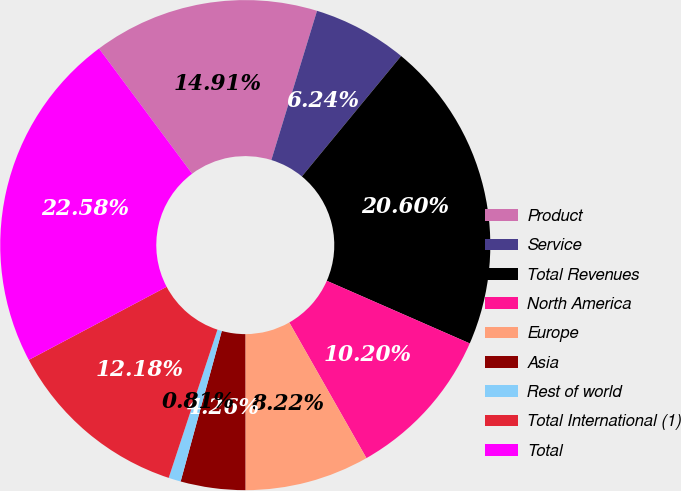Convert chart to OTSL. <chart><loc_0><loc_0><loc_500><loc_500><pie_chart><fcel>Product<fcel>Service<fcel>Total Revenues<fcel>North America<fcel>Europe<fcel>Asia<fcel>Rest of world<fcel>Total International (1)<fcel>Total<nl><fcel>14.91%<fcel>6.24%<fcel>20.6%<fcel>10.2%<fcel>8.22%<fcel>4.26%<fcel>0.81%<fcel>12.18%<fcel>22.58%<nl></chart> 